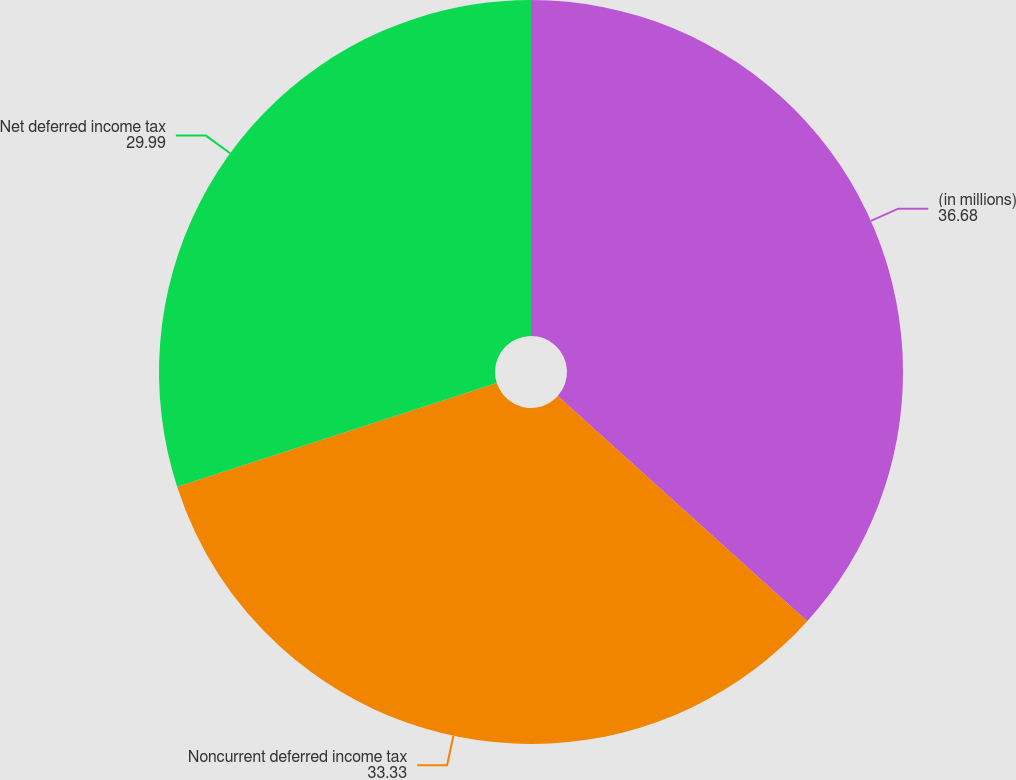Convert chart. <chart><loc_0><loc_0><loc_500><loc_500><pie_chart><fcel>(in millions)<fcel>Noncurrent deferred income tax<fcel>Net deferred income tax<nl><fcel>36.68%<fcel>33.33%<fcel>29.99%<nl></chart> 